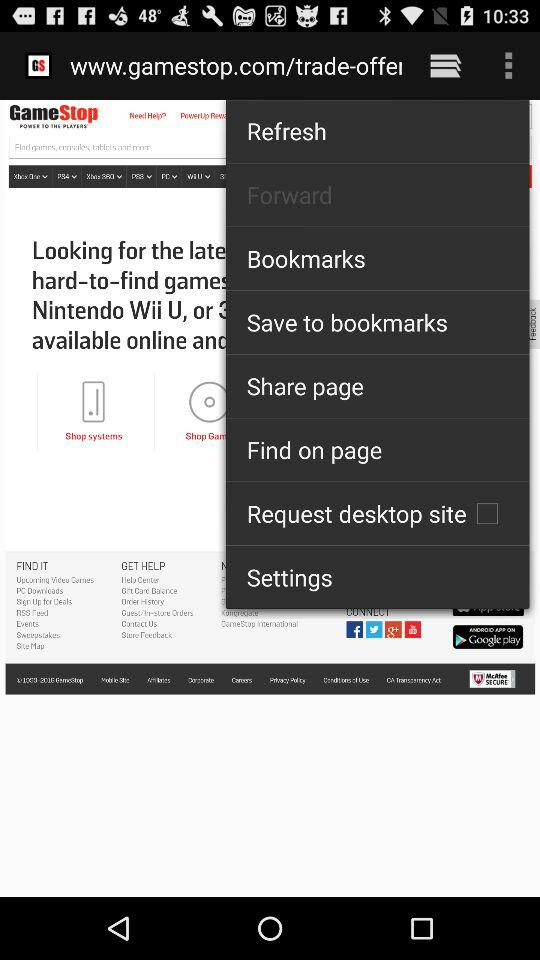What is the status of the "Request desktop site" setting? The status of the "Request desktop site" setting is "off". 